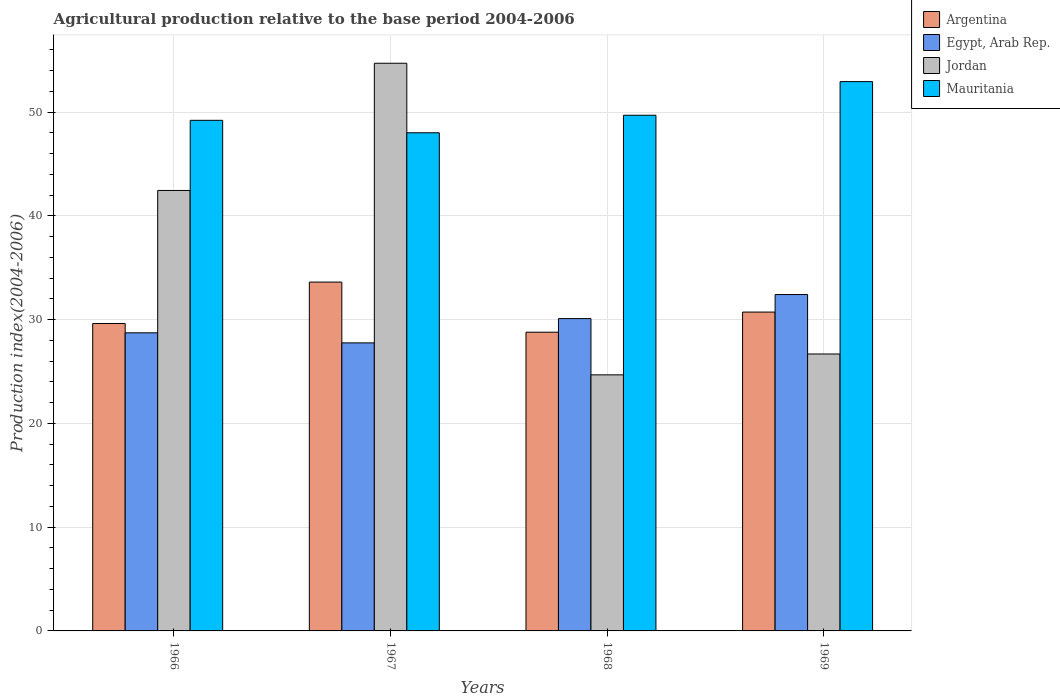Are the number of bars on each tick of the X-axis equal?
Your response must be concise. Yes. How many bars are there on the 1st tick from the left?
Make the answer very short. 4. What is the label of the 3rd group of bars from the left?
Your answer should be compact. 1968. In how many cases, is the number of bars for a given year not equal to the number of legend labels?
Provide a succinct answer. 0. What is the agricultural production index in Mauritania in 1968?
Give a very brief answer. 49.7. Across all years, what is the maximum agricultural production index in Argentina?
Offer a terse response. 33.62. Across all years, what is the minimum agricultural production index in Jordan?
Your answer should be very brief. 24.68. In which year was the agricultural production index in Mauritania maximum?
Your response must be concise. 1969. In which year was the agricultural production index in Mauritania minimum?
Make the answer very short. 1967. What is the total agricultural production index in Argentina in the graph?
Your answer should be very brief. 122.77. What is the difference between the agricultural production index in Mauritania in 1967 and that in 1968?
Keep it short and to the point. -1.69. What is the difference between the agricultural production index in Egypt, Arab Rep. in 1968 and the agricultural production index in Jordan in 1969?
Ensure brevity in your answer.  3.41. What is the average agricultural production index in Jordan per year?
Offer a very short reply. 37.13. In the year 1969, what is the difference between the agricultural production index in Egypt, Arab Rep. and agricultural production index in Argentina?
Provide a succinct answer. 1.69. What is the ratio of the agricultural production index in Mauritania in 1966 to that in 1967?
Ensure brevity in your answer.  1.02. Is the agricultural production index in Mauritania in 1967 less than that in 1969?
Ensure brevity in your answer.  Yes. Is the difference between the agricultural production index in Egypt, Arab Rep. in 1967 and 1968 greater than the difference between the agricultural production index in Argentina in 1967 and 1968?
Your answer should be very brief. No. What is the difference between the highest and the second highest agricultural production index in Egypt, Arab Rep.?
Your answer should be compact. 2.32. What is the difference between the highest and the lowest agricultural production index in Argentina?
Offer a very short reply. 4.83. What does the 4th bar from the left in 1966 represents?
Ensure brevity in your answer.  Mauritania. Is it the case that in every year, the sum of the agricultural production index in Jordan and agricultural production index in Mauritania is greater than the agricultural production index in Egypt, Arab Rep.?
Offer a terse response. Yes. How many bars are there?
Offer a very short reply. 16. Are all the bars in the graph horizontal?
Your response must be concise. No. What is the difference between two consecutive major ticks on the Y-axis?
Offer a terse response. 10. Does the graph contain any zero values?
Your answer should be very brief. No. How are the legend labels stacked?
Keep it short and to the point. Vertical. What is the title of the graph?
Your response must be concise. Agricultural production relative to the base period 2004-2006. Does "Qatar" appear as one of the legend labels in the graph?
Give a very brief answer. No. What is the label or title of the Y-axis?
Keep it short and to the point. Production index(2004-2006). What is the Production index(2004-2006) of Argentina in 1966?
Offer a very short reply. 29.63. What is the Production index(2004-2006) in Egypt, Arab Rep. in 1966?
Your answer should be compact. 28.73. What is the Production index(2004-2006) in Jordan in 1966?
Make the answer very short. 42.45. What is the Production index(2004-2006) in Mauritania in 1966?
Keep it short and to the point. 49.21. What is the Production index(2004-2006) of Argentina in 1967?
Keep it short and to the point. 33.62. What is the Production index(2004-2006) of Egypt, Arab Rep. in 1967?
Your response must be concise. 27.76. What is the Production index(2004-2006) in Jordan in 1967?
Provide a succinct answer. 54.71. What is the Production index(2004-2006) of Mauritania in 1967?
Give a very brief answer. 48.01. What is the Production index(2004-2006) in Argentina in 1968?
Your response must be concise. 28.79. What is the Production index(2004-2006) of Egypt, Arab Rep. in 1968?
Keep it short and to the point. 30.1. What is the Production index(2004-2006) of Jordan in 1968?
Offer a terse response. 24.68. What is the Production index(2004-2006) of Mauritania in 1968?
Provide a succinct answer. 49.7. What is the Production index(2004-2006) in Argentina in 1969?
Offer a terse response. 30.73. What is the Production index(2004-2006) in Egypt, Arab Rep. in 1969?
Your answer should be compact. 32.42. What is the Production index(2004-2006) in Jordan in 1969?
Your answer should be very brief. 26.69. What is the Production index(2004-2006) in Mauritania in 1969?
Make the answer very short. 52.94. Across all years, what is the maximum Production index(2004-2006) in Argentina?
Your response must be concise. 33.62. Across all years, what is the maximum Production index(2004-2006) of Egypt, Arab Rep.?
Your answer should be very brief. 32.42. Across all years, what is the maximum Production index(2004-2006) in Jordan?
Your answer should be very brief. 54.71. Across all years, what is the maximum Production index(2004-2006) of Mauritania?
Offer a very short reply. 52.94. Across all years, what is the minimum Production index(2004-2006) in Argentina?
Keep it short and to the point. 28.79. Across all years, what is the minimum Production index(2004-2006) in Egypt, Arab Rep.?
Offer a very short reply. 27.76. Across all years, what is the minimum Production index(2004-2006) in Jordan?
Offer a terse response. 24.68. Across all years, what is the minimum Production index(2004-2006) in Mauritania?
Give a very brief answer. 48.01. What is the total Production index(2004-2006) in Argentina in the graph?
Keep it short and to the point. 122.77. What is the total Production index(2004-2006) in Egypt, Arab Rep. in the graph?
Provide a succinct answer. 119.01. What is the total Production index(2004-2006) of Jordan in the graph?
Give a very brief answer. 148.53. What is the total Production index(2004-2006) in Mauritania in the graph?
Offer a terse response. 199.86. What is the difference between the Production index(2004-2006) of Argentina in 1966 and that in 1967?
Your answer should be very brief. -3.99. What is the difference between the Production index(2004-2006) in Egypt, Arab Rep. in 1966 and that in 1967?
Provide a succinct answer. 0.97. What is the difference between the Production index(2004-2006) of Jordan in 1966 and that in 1967?
Give a very brief answer. -12.26. What is the difference between the Production index(2004-2006) in Mauritania in 1966 and that in 1967?
Provide a succinct answer. 1.2. What is the difference between the Production index(2004-2006) in Argentina in 1966 and that in 1968?
Provide a short and direct response. 0.84. What is the difference between the Production index(2004-2006) of Egypt, Arab Rep. in 1966 and that in 1968?
Give a very brief answer. -1.37. What is the difference between the Production index(2004-2006) in Jordan in 1966 and that in 1968?
Your answer should be compact. 17.77. What is the difference between the Production index(2004-2006) of Mauritania in 1966 and that in 1968?
Keep it short and to the point. -0.49. What is the difference between the Production index(2004-2006) in Argentina in 1966 and that in 1969?
Provide a succinct answer. -1.1. What is the difference between the Production index(2004-2006) in Egypt, Arab Rep. in 1966 and that in 1969?
Your answer should be very brief. -3.69. What is the difference between the Production index(2004-2006) in Jordan in 1966 and that in 1969?
Offer a terse response. 15.76. What is the difference between the Production index(2004-2006) of Mauritania in 1966 and that in 1969?
Give a very brief answer. -3.73. What is the difference between the Production index(2004-2006) of Argentina in 1967 and that in 1968?
Offer a terse response. 4.83. What is the difference between the Production index(2004-2006) in Egypt, Arab Rep. in 1967 and that in 1968?
Offer a terse response. -2.34. What is the difference between the Production index(2004-2006) of Jordan in 1967 and that in 1968?
Keep it short and to the point. 30.03. What is the difference between the Production index(2004-2006) of Mauritania in 1967 and that in 1968?
Make the answer very short. -1.69. What is the difference between the Production index(2004-2006) of Argentina in 1967 and that in 1969?
Give a very brief answer. 2.89. What is the difference between the Production index(2004-2006) of Egypt, Arab Rep. in 1967 and that in 1969?
Offer a very short reply. -4.66. What is the difference between the Production index(2004-2006) in Jordan in 1967 and that in 1969?
Offer a very short reply. 28.02. What is the difference between the Production index(2004-2006) in Mauritania in 1967 and that in 1969?
Provide a succinct answer. -4.93. What is the difference between the Production index(2004-2006) of Argentina in 1968 and that in 1969?
Offer a terse response. -1.94. What is the difference between the Production index(2004-2006) in Egypt, Arab Rep. in 1968 and that in 1969?
Make the answer very short. -2.32. What is the difference between the Production index(2004-2006) in Jordan in 1968 and that in 1969?
Ensure brevity in your answer.  -2.01. What is the difference between the Production index(2004-2006) in Mauritania in 1968 and that in 1969?
Give a very brief answer. -3.24. What is the difference between the Production index(2004-2006) of Argentina in 1966 and the Production index(2004-2006) of Egypt, Arab Rep. in 1967?
Your answer should be compact. 1.87. What is the difference between the Production index(2004-2006) of Argentina in 1966 and the Production index(2004-2006) of Jordan in 1967?
Your answer should be very brief. -25.08. What is the difference between the Production index(2004-2006) in Argentina in 1966 and the Production index(2004-2006) in Mauritania in 1967?
Your answer should be very brief. -18.38. What is the difference between the Production index(2004-2006) in Egypt, Arab Rep. in 1966 and the Production index(2004-2006) in Jordan in 1967?
Your response must be concise. -25.98. What is the difference between the Production index(2004-2006) of Egypt, Arab Rep. in 1966 and the Production index(2004-2006) of Mauritania in 1967?
Make the answer very short. -19.28. What is the difference between the Production index(2004-2006) in Jordan in 1966 and the Production index(2004-2006) in Mauritania in 1967?
Your answer should be compact. -5.56. What is the difference between the Production index(2004-2006) of Argentina in 1966 and the Production index(2004-2006) of Egypt, Arab Rep. in 1968?
Offer a terse response. -0.47. What is the difference between the Production index(2004-2006) in Argentina in 1966 and the Production index(2004-2006) in Jordan in 1968?
Give a very brief answer. 4.95. What is the difference between the Production index(2004-2006) in Argentina in 1966 and the Production index(2004-2006) in Mauritania in 1968?
Provide a short and direct response. -20.07. What is the difference between the Production index(2004-2006) in Egypt, Arab Rep. in 1966 and the Production index(2004-2006) in Jordan in 1968?
Your answer should be very brief. 4.05. What is the difference between the Production index(2004-2006) of Egypt, Arab Rep. in 1966 and the Production index(2004-2006) of Mauritania in 1968?
Make the answer very short. -20.97. What is the difference between the Production index(2004-2006) in Jordan in 1966 and the Production index(2004-2006) in Mauritania in 1968?
Offer a very short reply. -7.25. What is the difference between the Production index(2004-2006) in Argentina in 1966 and the Production index(2004-2006) in Egypt, Arab Rep. in 1969?
Ensure brevity in your answer.  -2.79. What is the difference between the Production index(2004-2006) of Argentina in 1966 and the Production index(2004-2006) of Jordan in 1969?
Your response must be concise. 2.94. What is the difference between the Production index(2004-2006) of Argentina in 1966 and the Production index(2004-2006) of Mauritania in 1969?
Offer a very short reply. -23.31. What is the difference between the Production index(2004-2006) in Egypt, Arab Rep. in 1966 and the Production index(2004-2006) in Jordan in 1969?
Keep it short and to the point. 2.04. What is the difference between the Production index(2004-2006) in Egypt, Arab Rep. in 1966 and the Production index(2004-2006) in Mauritania in 1969?
Give a very brief answer. -24.21. What is the difference between the Production index(2004-2006) in Jordan in 1966 and the Production index(2004-2006) in Mauritania in 1969?
Ensure brevity in your answer.  -10.49. What is the difference between the Production index(2004-2006) of Argentina in 1967 and the Production index(2004-2006) of Egypt, Arab Rep. in 1968?
Make the answer very short. 3.52. What is the difference between the Production index(2004-2006) in Argentina in 1967 and the Production index(2004-2006) in Jordan in 1968?
Offer a terse response. 8.94. What is the difference between the Production index(2004-2006) of Argentina in 1967 and the Production index(2004-2006) of Mauritania in 1968?
Your response must be concise. -16.08. What is the difference between the Production index(2004-2006) in Egypt, Arab Rep. in 1967 and the Production index(2004-2006) in Jordan in 1968?
Make the answer very short. 3.08. What is the difference between the Production index(2004-2006) in Egypt, Arab Rep. in 1967 and the Production index(2004-2006) in Mauritania in 1968?
Keep it short and to the point. -21.94. What is the difference between the Production index(2004-2006) in Jordan in 1967 and the Production index(2004-2006) in Mauritania in 1968?
Ensure brevity in your answer.  5.01. What is the difference between the Production index(2004-2006) of Argentina in 1967 and the Production index(2004-2006) of Jordan in 1969?
Provide a short and direct response. 6.93. What is the difference between the Production index(2004-2006) of Argentina in 1967 and the Production index(2004-2006) of Mauritania in 1969?
Make the answer very short. -19.32. What is the difference between the Production index(2004-2006) of Egypt, Arab Rep. in 1967 and the Production index(2004-2006) of Jordan in 1969?
Provide a short and direct response. 1.07. What is the difference between the Production index(2004-2006) in Egypt, Arab Rep. in 1967 and the Production index(2004-2006) in Mauritania in 1969?
Ensure brevity in your answer.  -25.18. What is the difference between the Production index(2004-2006) of Jordan in 1967 and the Production index(2004-2006) of Mauritania in 1969?
Keep it short and to the point. 1.77. What is the difference between the Production index(2004-2006) in Argentina in 1968 and the Production index(2004-2006) in Egypt, Arab Rep. in 1969?
Your answer should be very brief. -3.63. What is the difference between the Production index(2004-2006) of Argentina in 1968 and the Production index(2004-2006) of Mauritania in 1969?
Your answer should be very brief. -24.15. What is the difference between the Production index(2004-2006) in Egypt, Arab Rep. in 1968 and the Production index(2004-2006) in Jordan in 1969?
Offer a terse response. 3.41. What is the difference between the Production index(2004-2006) of Egypt, Arab Rep. in 1968 and the Production index(2004-2006) of Mauritania in 1969?
Offer a very short reply. -22.84. What is the difference between the Production index(2004-2006) in Jordan in 1968 and the Production index(2004-2006) in Mauritania in 1969?
Ensure brevity in your answer.  -28.26. What is the average Production index(2004-2006) in Argentina per year?
Provide a succinct answer. 30.69. What is the average Production index(2004-2006) of Egypt, Arab Rep. per year?
Offer a very short reply. 29.75. What is the average Production index(2004-2006) in Jordan per year?
Your answer should be compact. 37.13. What is the average Production index(2004-2006) of Mauritania per year?
Offer a very short reply. 49.97. In the year 1966, what is the difference between the Production index(2004-2006) in Argentina and Production index(2004-2006) in Jordan?
Your response must be concise. -12.82. In the year 1966, what is the difference between the Production index(2004-2006) of Argentina and Production index(2004-2006) of Mauritania?
Offer a terse response. -19.58. In the year 1966, what is the difference between the Production index(2004-2006) in Egypt, Arab Rep. and Production index(2004-2006) in Jordan?
Ensure brevity in your answer.  -13.72. In the year 1966, what is the difference between the Production index(2004-2006) of Egypt, Arab Rep. and Production index(2004-2006) of Mauritania?
Ensure brevity in your answer.  -20.48. In the year 1966, what is the difference between the Production index(2004-2006) in Jordan and Production index(2004-2006) in Mauritania?
Your answer should be very brief. -6.76. In the year 1967, what is the difference between the Production index(2004-2006) of Argentina and Production index(2004-2006) of Egypt, Arab Rep.?
Provide a short and direct response. 5.86. In the year 1967, what is the difference between the Production index(2004-2006) of Argentina and Production index(2004-2006) of Jordan?
Your answer should be compact. -21.09. In the year 1967, what is the difference between the Production index(2004-2006) of Argentina and Production index(2004-2006) of Mauritania?
Give a very brief answer. -14.39. In the year 1967, what is the difference between the Production index(2004-2006) of Egypt, Arab Rep. and Production index(2004-2006) of Jordan?
Keep it short and to the point. -26.95. In the year 1967, what is the difference between the Production index(2004-2006) of Egypt, Arab Rep. and Production index(2004-2006) of Mauritania?
Keep it short and to the point. -20.25. In the year 1968, what is the difference between the Production index(2004-2006) of Argentina and Production index(2004-2006) of Egypt, Arab Rep.?
Offer a very short reply. -1.31. In the year 1968, what is the difference between the Production index(2004-2006) in Argentina and Production index(2004-2006) in Jordan?
Ensure brevity in your answer.  4.11. In the year 1968, what is the difference between the Production index(2004-2006) in Argentina and Production index(2004-2006) in Mauritania?
Give a very brief answer. -20.91. In the year 1968, what is the difference between the Production index(2004-2006) of Egypt, Arab Rep. and Production index(2004-2006) of Jordan?
Keep it short and to the point. 5.42. In the year 1968, what is the difference between the Production index(2004-2006) in Egypt, Arab Rep. and Production index(2004-2006) in Mauritania?
Make the answer very short. -19.6. In the year 1968, what is the difference between the Production index(2004-2006) in Jordan and Production index(2004-2006) in Mauritania?
Keep it short and to the point. -25.02. In the year 1969, what is the difference between the Production index(2004-2006) of Argentina and Production index(2004-2006) of Egypt, Arab Rep.?
Keep it short and to the point. -1.69. In the year 1969, what is the difference between the Production index(2004-2006) of Argentina and Production index(2004-2006) of Jordan?
Provide a succinct answer. 4.04. In the year 1969, what is the difference between the Production index(2004-2006) of Argentina and Production index(2004-2006) of Mauritania?
Your answer should be very brief. -22.21. In the year 1969, what is the difference between the Production index(2004-2006) of Egypt, Arab Rep. and Production index(2004-2006) of Jordan?
Your answer should be compact. 5.73. In the year 1969, what is the difference between the Production index(2004-2006) in Egypt, Arab Rep. and Production index(2004-2006) in Mauritania?
Make the answer very short. -20.52. In the year 1969, what is the difference between the Production index(2004-2006) in Jordan and Production index(2004-2006) in Mauritania?
Your answer should be compact. -26.25. What is the ratio of the Production index(2004-2006) in Argentina in 1966 to that in 1967?
Give a very brief answer. 0.88. What is the ratio of the Production index(2004-2006) of Egypt, Arab Rep. in 1966 to that in 1967?
Provide a succinct answer. 1.03. What is the ratio of the Production index(2004-2006) in Jordan in 1966 to that in 1967?
Your response must be concise. 0.78. What is the ratio of the Production index(2004-2006) in Mauritania in 1966 to that in 1967?
Your response must be concise. 1.02. What is the ratio of the Production index(2004-2006) in Argentina in 1966 to that in 1968?
Give a very brief answer. 1.03. What is the ratio of the Production index(2004-2006) of Egypt, Arab Rep. in 1966 to that in 1968?
Offer a very short reply. 0.95. What is the ratio of the Production index(2004-2006) in Jordan in 1966 to that in 1968?
Provide a succinct answer. 1.72. What is the ratio of the Production index(2004-2006) in Mauritania in 1966 to that in 1968?
Offer a terse response. 0.99. What is the ratio of the Production index(2004-2006) of Argentina in 1966 to that in 1969?
Offer a very short reply. 0.96. What is the ratio of the Production index(2004-2006) of Egypt, Arab Rep. in 1966 to that in 1969?
Give a very brief answer. 0.89. What is the ratio of the Production index(2004-2006) in Jordan in 1966 to that in 1969?
Provide a succinct answer. 1.59. What is the ratio of the Production index(2004-2006) in Mauritania in 1966 to that in 1969?
Your answer should be very brief. 0.93. What is the ratio of the Production index(2004-2006) in Argentina in 1967 to that in 1968?
Keep it short and to the point. 1.17. What is the ratio of the Production index(2004-2006) of Egypt, Arab Rep. in 1967 to that in 1968?
Make the answer very short. 0.92. What is the ratio of the Production index(2004-2006) of Jordan in 1967 to that in 1968?
Your answer should be very brief. 2.22. What is the ratio of the Production index(2004-2006) in Mauritania in 1967 to that in 1968?
Provide a succinct answer. 0.97. What is the ratio of the Production index(2004-2006) of Argentina in 1967 to that in 1969?
Offer a terse response. 1.09. What is the ratio of the Production index(2004-2006) of Egypt, Arab Rep. in 1967 to that in 1969?
Ensure brevity in your answer.  0.86. What is the ratio of the Production index(2004-2006) in Jordan in 1967 to that in 1969?
Ensure brevity in your answer.  2.05. What is the ratio of the Production index(2004-2006) in Mauritania in 1967 to that in 1969?
Your answer should be very brief. 0.91. What is the ratio of the Production index(2004-2006) in Argentina in 1968 to that in 1969?
Ensure brevity in your answer.  0.94. What is the ratio of the Production index(2004-2006) in Egypt, Arab Rep. in 1968 to that in 1969?
Provide a short and direct response. 0.93. What is the ratio of the Production index(2004-2006) of Jordan in 1968 to that in 1969?
Provide a succinct answer. 0.92. What is the ratio of the Production index(2004-2006) of Mauritania in 1968 to that in 1969?
Keep it short and to the point. 0.94. What is the difference between the highest and the second highest Production index(2004-2006) in Argentina?
Keep it short and to the point. 2.89. What is the difference between the highest and the second highest Production index(2004-2006) in Egypt, Arab Rep.?
Provide a succinct answer. 2.32. What is the difference between the highest and the second highest Production index(2004-2006) in Jordan?
Offer a very short reply. 12.26. What is the difference between the highest and the second highest Production index(2004-2006) of Mauritania?
Provide a succinct answer. 3.24. What is the difference between the highest and the lowest Production index(2004-2006) of Argentina?
Offer a terse response. 4.83. What is the difference between the highest and the lowest Production index(2004-2006) in Egypt, Arab Rep.?
Make the answer very short. 4.66. What is the difference between the highest and the lowest Production index(2004-2006) in Jordan?
Keep it short and to the point. 30.03. What is the difference between the highest and the lowest Production index(2004-2006) of Mauritania?
Your answer should be compact. 4.93. 